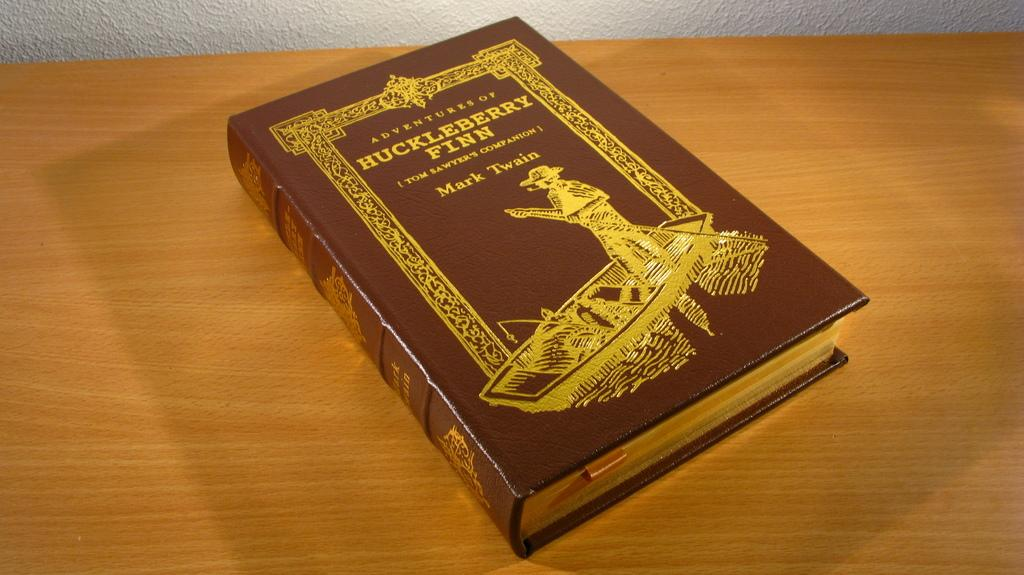<image>
Create a compact narrative representing the image presented. A leatherbound copy of Huckleberry Finn by Mark Twain. 